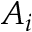<formula> <loc_0><loc_0><loc_500><loc_500>A _ { i }</formula> 